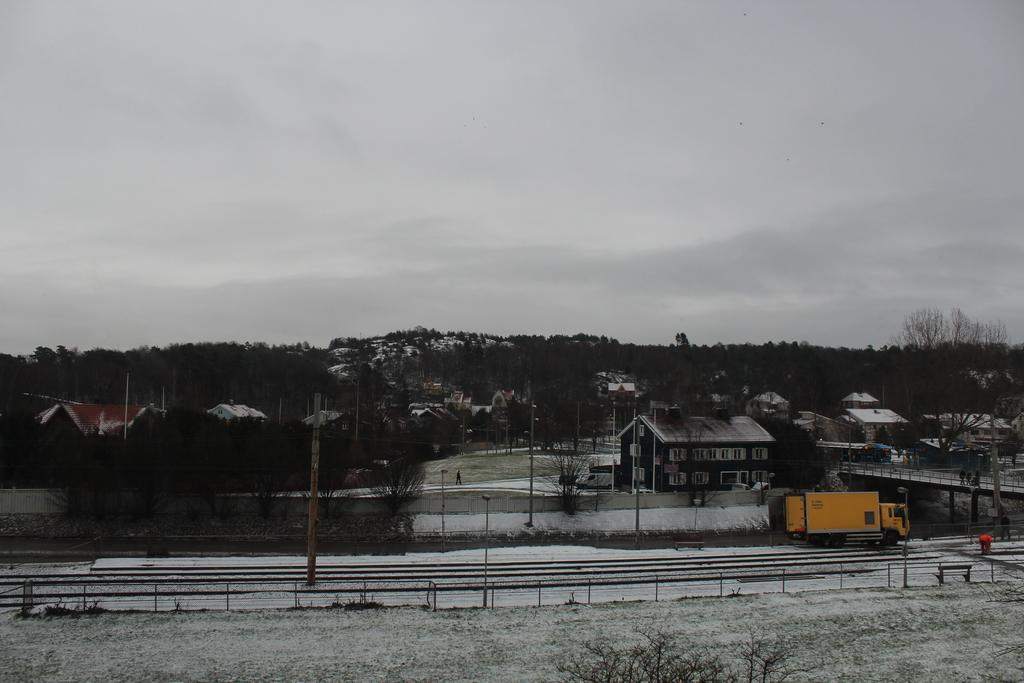What type of structures can be seen in the image? There are houses in the image. What other natural elements are present in the image? There are trees in the image. What mode of transportation is visible on the road? There is a truck on the road in the image. What object can be seen standing upright in the image? There is a pole in the image. What type of outdoor seating is available in the image? There is a bench in the image. What part of the natural environment is visible in the image? The sky is visible in the image. What weather condition is depicted in the image? There is snow in the image. What type of dinner is being served on the bench in the image? There is no dinner or food present on the bench in the image. Can you tell me the age of the grandfather sitting on the bench in the image? There is no person, let alone a grandfather, depicted on the bench in the image. How many planes can be seen flying in the sky in the image? There are no planes visible in the sky in the image. 